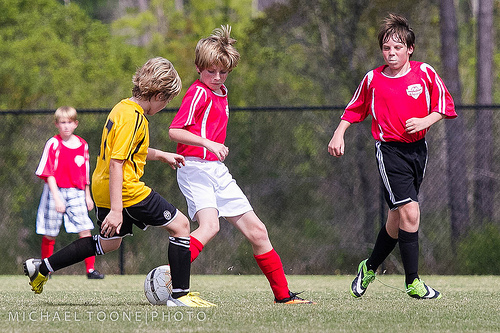<image>
Is the red shirt on the boy? No. The red shirt is not positioned on the boy. They may be near each other, but the red shirt is not supported by or resting on top of the boy. 